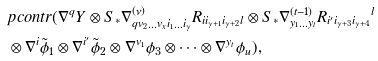<formula> <loc_0><loc_0><loc_500><loc_500>& p c o n t r ( \nabla ^ { q } Y \otimes S _ { * } \nabla ^ { ( \nu ) } _ { q v _ { 2 } \dots v _ { x } i _ { 1 } \dots i _ { \gamma } } R _ { i i _ { \gamma + 1 } i _ { \gamma + 2 } l } \otimes S _ { * } \nabla ^ { ( t - 1 ) } _ { y _ { 1 } \dots y _ { t } } { R _ { i ^ { \prime } i _ { \gamma + 3 } i _ { \gamma + 4 } } } ^ { l } \\ & \otimes \nabla ^ { i } \tilde { \phi } _ { 1 } \otimes \nabla ^ { i ^ { \prime } } \tilde { \phi } _ { 2 } \otimes \nabla ^ { v _ { 1 } } \phi _ { 3 } \otimes \dots \otimes \nabla ^ { y _ { t } } \phi _ { u } ) ,</formula> 